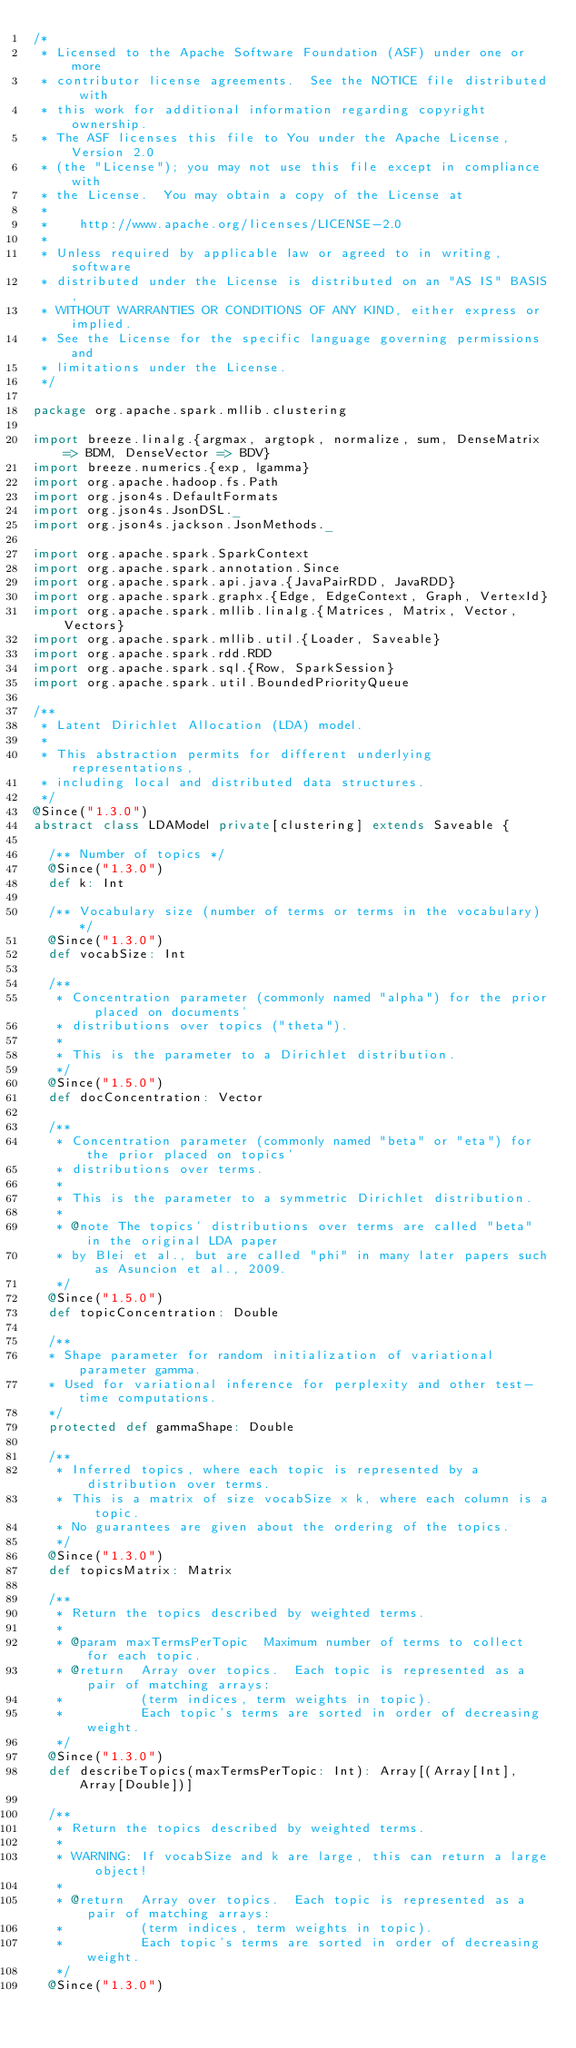<code> <loc_0><loc_0><loc_500><loc_500><_Scala_>/*
 * Licensed to the Apache Software Foundation (ASF) under one or more
 * contributor license agreements.  See the NOTICE file distributed with
 * this work for additional information regarding copyright ownership.
 * The ASF licenses this file to You under the Apache License, Version 2.0
 * (the "License"); you may not use this file except in compliance with
 * the License.  You may obtain a copy of the License at
 *
 *    http://www.apache.org/licenses/LICENSE-2.0
 *
 * Unless required by applicable law or agreed to in writing, software
 * distributed under the License is distributed on an "AS IS" BASIS,
 * WITHOUT WARRANTIES OR CONDITIONS OF ANY KIND, either express or implied.
 * See the License for the specific language governing permissions and
 * limitations under the License.
 */

package org.apache.spark.mllib.clustering

import breeze.linalg.{argmax, argtopk, normalize, sum, DenseMatrix => BDM, DenseVector => BDV}
import breeze.numerics.{exp, lgamma}
import org.apache.hadoop.fs.Path
import org.json4s.DefaultFormats
import org.json4s.JsonDSL._
import org.json4s.jackson.JsonMethods._

import org.apache.spark.SparkContext
import org.apache.spark.annotation.Since
import org.apache.spark.api.java.{JavaPairRDD, JavaRDD}
import org.apache.spark.graphx.{Edge, EdgeContext, Graph, VertexId}
import org.apache.spark.mllib.linalg.{Matrices, Matrix, Vector, Vectors}
import org.apache.spark.mllib.util.{Loader, Saveable}
import org.apache.spark.rdd.RDD
import org.apache.spark.sql.{Row, SparkSession}
import org.apache.spark.util.BoundedPriorityQueue

/**
 * Latent Dirichlet Allocation (LDA) model.
 *
 * This abstraction permits for different underlying representations,
 * including local and distributed data structures.
 */
@Since("1.3.0")
abstract class LDAModel private[clustering] extends Saveable {

  /** Number of topics */
  @Since("1.3.0")
  def k: Int

  /** Vocabulary size (number of terms or terms in the vocabulary) */
  @Since("1.3.0")
  def vocabSize: Int

  /**
   * Concentration parameter (commonly named "alpha") for the prior placed on documents'
   * distributions over topics ("theta").
   *
   * This is the parameter to a Dirichlet distribution.
   */
  @Since("1.5.0")
  def docConcentration: Vector

  /**
   * Concentration parameter (commonly named "beta" or "eta") for the prior placed on topics'
   * distributions over terms.
   *
   * This is the parameter to a symmetric Dirichlet distribution.
   *
   * @note The topics' distributions over terms are called "beta" in the original LDA paper
   * by Blei et al., but are called "phi" in many later papers such as Asuncion et al., 2009.
   */
  @Since("1.5.0")
  def topicConcentration: Double

  /**
  * Shape parameter for random initialization of variational parameter gamma.
  * Used for variational inference for perplexity and other test-time computations.
  */
  protected def gammaShape: Double

  /**
   * Inferred topics, where each topic is represented by a distribution over terms.
   * This is a matrix of size vocabSize x k, where each column is a topic.
   * No guarantees are given about the ordering of the topics.
   */
  @Since("1.3.0")
  def topicsMatrix: Matrix

  /**
   * Return the topics described by weighted terms.
   *
   * @param maxTermsPerTopic  Maximum number of terms to collect for each topic.
   * @return  Array over topics.  Each topic is represented as a pair of matching arrays:
   *          (term indices, term weights in topic).
   *          Each topic's terms are sorted in order of decreasing weight.
   */
  @Since("1.3.0")
  def describeTopics(maxTermsPerTopic: Int): Array[(Array[Int], Array[Double])]

  /**
   * Return the topics described by weighted terms.
   *
   * WARNING: If vocabSize and k are large, this can return a large object!
   *
   * @return  Array over topics.  Each topic is represented as a pair of matching arrays:
   *          (term indices, term weights in topic).
   *          Each topic's terms are sorted in order of decreasing weight.
   */
  @Since("1.3.0")</code> 